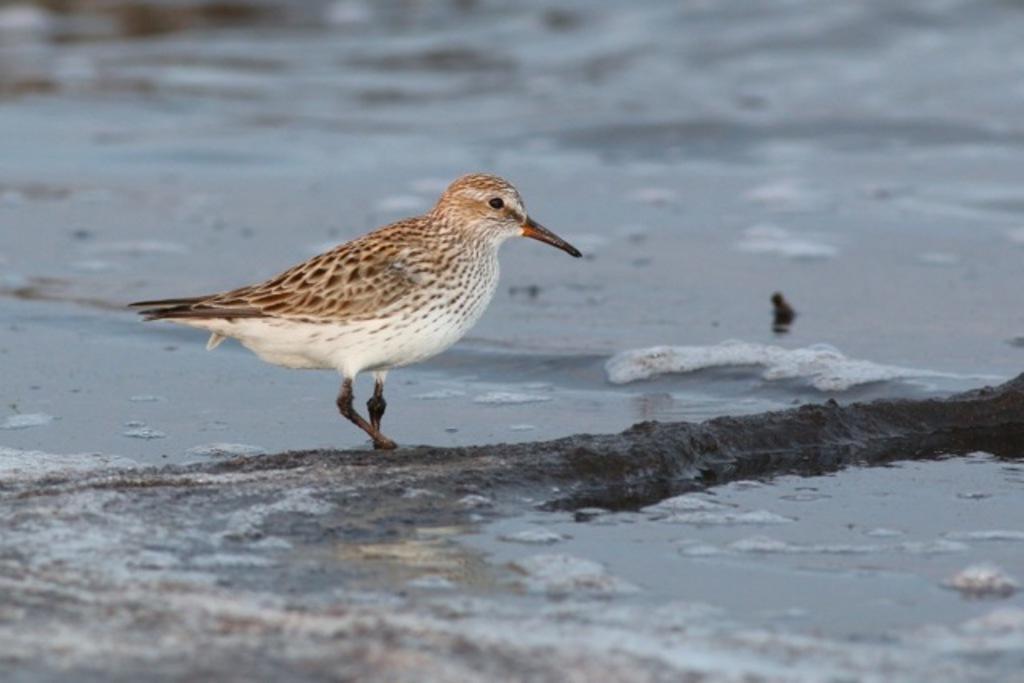How would you summarize this image in a sentence or two? In this image we can see there is a bird on the sand. In the background there is a river. 